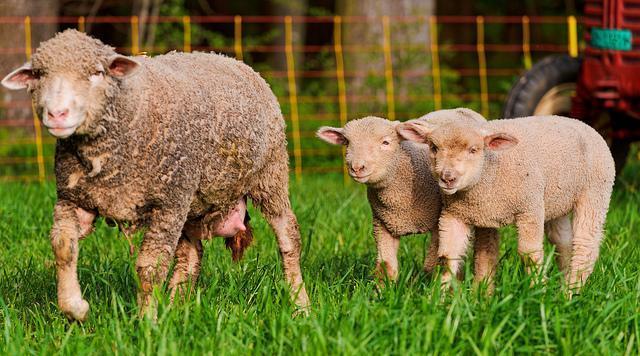How many baby sheep are in the picture?
Give a very brief answer. 2. How many sheep can be seen?
Give a very brief answer. 3. How many elephants are in the picture?
Give a very brief answer. 0. 